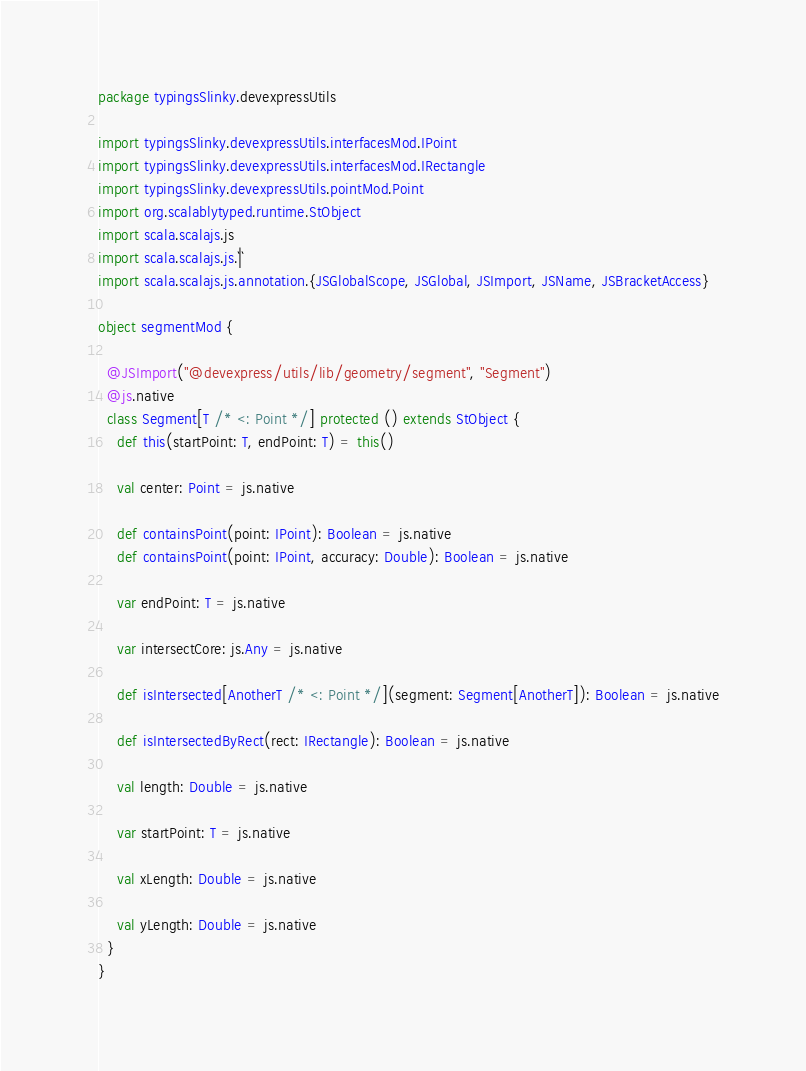Convert code to text. <code><loc_0><loc_0><loc_500><loc_500><_Scala_>package typingsSlinky.devexpressUtils

import typingsSlinky.devexpressUtils.interfacesMod.IPoint
import typingsSlinky.devexpressUtils.interfacesMod.IRectangle
import typingsSlinky.devexpressUtils.pointMod.Point
import org.scalablytyped.runtime.StObject
import scala.scalajs.js
import scala.scalajs.js.`|`
import scala.scalajs.js.annotation.{JSGlobalScope, JSGlobal, JSImport, JSName, JSBracketAccess}

object segmentMod {
  
  @JSImport("@devexpress/utils/lib/geometry/segment", "Segment")
  @js.native
  class Segment[T /* <: Point */] protected () extends StObject {
    def this(startPoint: T, endPoint: T) = this()
    
    val center: Point = js.native
    
    def containsPoint(point: IPoint): Boolean = js.native
    def containsPoint(point: IPoint, accuracy: Double): Boolean = js.native
    
    var endPoint: T = js.native
    
    var intersectCore: js.Any = js.native
    
    def isIntersected[AnotherT /* <: Point */](segment: Segment[AnotherT]): Boolean = js.native
    
    def isIntersectedByRect(rect: IRectangle): Boolean = js.native
    
    val length: Double = js.native
    
    var startPoint: T = js.native
    
    val xLength: Double = js.native
    
    val yLength: Double = js.native
  }
}
</code> 